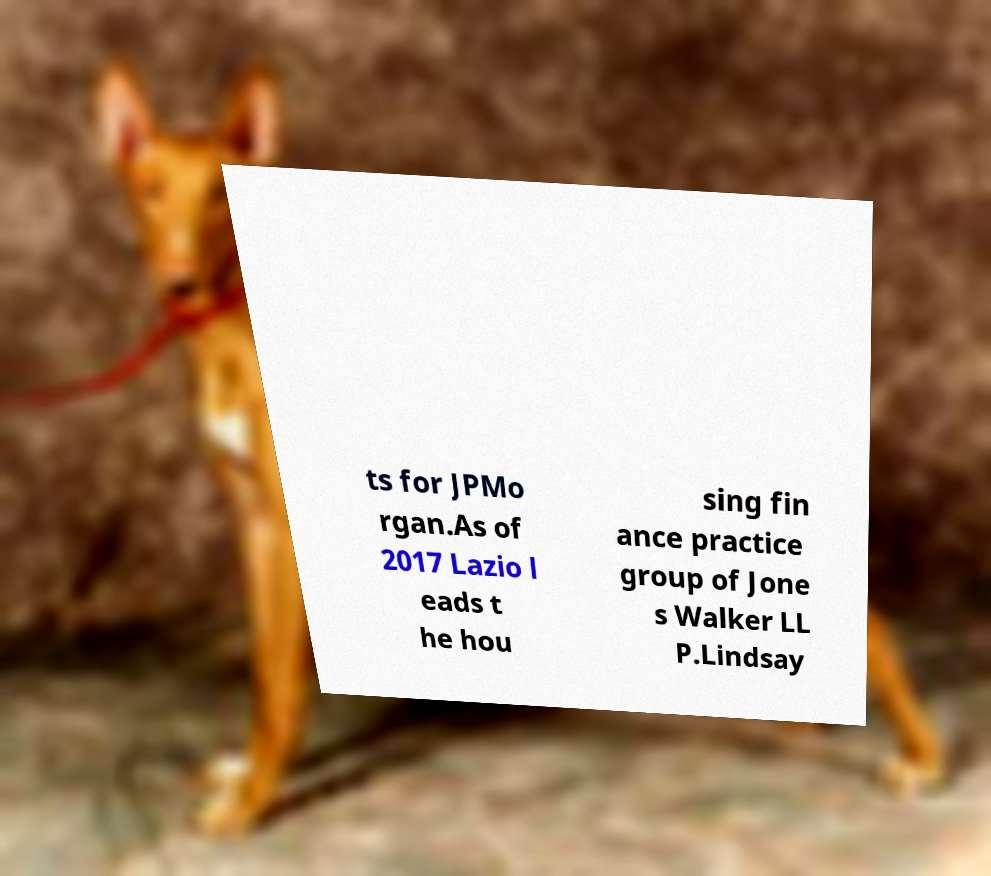There's text embedded in this image that I need extracted. Can you transcribe it verbatim? ts for JPMo rgan.As of 2017 Lazio l eads t he hou sing fin ance practice group of Jone s Walker LL P.Lindsay 